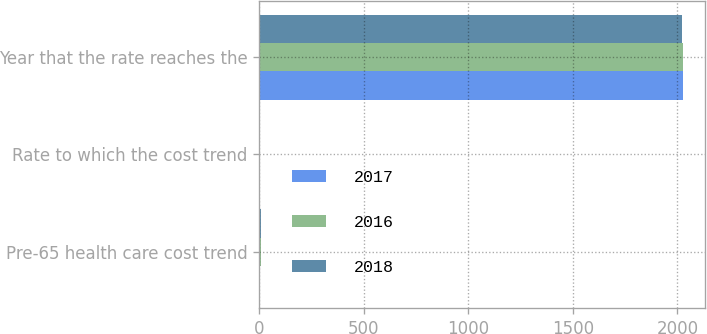<chart> <loc_0><loc_0><loc_500><loc_500><stacked_bar_chart><ecel><fcel>Pre-65 health care cost trend<fcel>Rate to which the cost trend<fcel>Year that the rate reaches the<nl><fcel>2017<fcel>6.5<fcel>4.5<fcel>2028<nl><fcel>2016<fcel>6.75<fcel>4.5<fcel>2028<nl><fcel>2018<fcel>6.9<fcel>5<fcel>2024<nl></chart> 